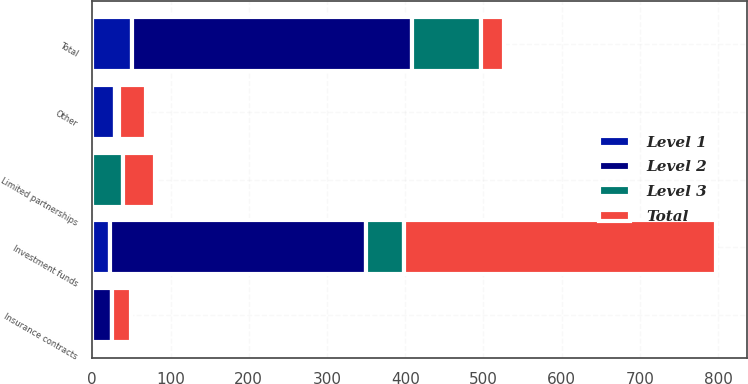Convert chart. <chart><loc_0><loc_0><loc_500><loc_500><stacked_bar_chart><ecel><fcel>Investment funds<fcel>Insurance contracts<fcel>Limited partnerships<fcel>Other<fcel>Total<nl><fcel>Level 1<fcel>22.3<fcel>0<fcel>0<fcel>28.6<fcel>50.9<nl><fcel>Level 2<fcel>327.9<fcel>24.8<fcel>0<fcel>5.5<fcel>358.2<nl><fcel>Level 3<fcel>48.2<fcel>0<fcel>39.8<fcel>0.3<fcel>88.3<nl><fcel>Total<fcel>398.4<fcel>24.8<fcel>39.8<fcel>34.4<fcel>28.6<nl></chart> 